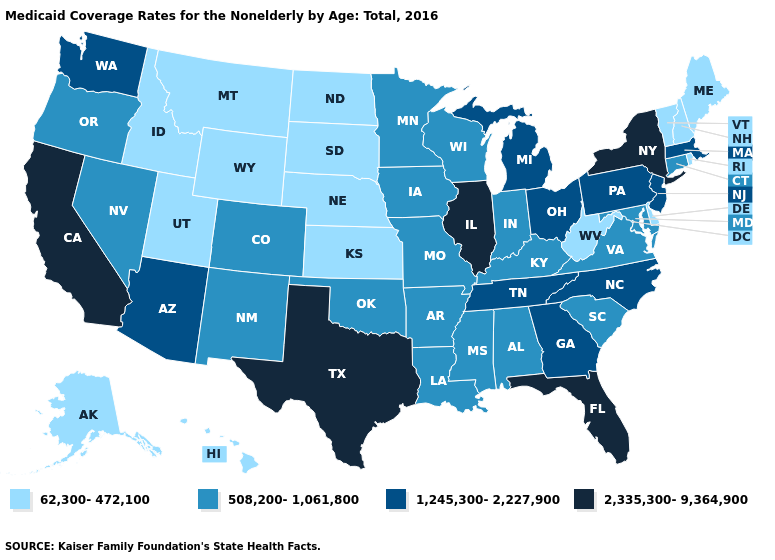Does Florida have the highest value in the South?
Short answer required. Yes. What is the value of Hawaii?
Short answer required. 62,300-472,100. What is the highest value in the South ?
Quick response, please. 2,335,300-9,364,900. What is the value of South Carolina?
Keep it brief. 508,200-1,061,800. Among the states that border North Carolina , does Georgia have the lowest value?
Answer briefly. No. What is the lowest value in the South?
Concise answer only. 62,300-472,100. What is the value of Massachusetts?
Give a very brief answer. 1,245,300-2,227,900. Name the states that have a value in the range 2,335,300-9,364,900?
Write a very short answer. California, Florida, Illinois, New York, Texas. Name the states that have a value in the range 508,200-1,061,800?
Keep it brief. Alabama, Arkansas, Colorado, Connecticut, Indiana, Iowa, Kentucky, Louisiana, Maryland, Minnesota, Mississippi, Missouri, Nevada, New Mexico, Oklahoma, Oregon, South Carolina, Virginia, Wisconsin. Does the map have missing data?
Short answer required. No. Does the first symbol in the legend represent the smallest category?
Short answer required. Yes. Name the states that have a value in the range 508,200-1,061,800?
Answer briefly. Alabama, Arkansas, Colorado, Connecticut, Indiana, Iowa, Kentucky, Louisiana, Maryland, Minnesota, Mississippi, Missouri, Nevada, New Mexico, Oklahoma, Oregon, South Carolina, Virginia, Wisconsin. Among the states that border Iowa , does South Dakota have the lowest value?
Quick response, please. Yes. What is the value of Minnesota?
Answer briefly. 508,200-1,061,800. Name the states that have a value in the range 508,200-1,061,800?
Keep it brief. Alabama, Arkansas, Colorado, Connecticut, Indiana, Iowa, Kentucky, Louisiana, Maryland, Minnesota, Mississippi, Missouri, Nevada, New Mexico, Oklahoma, Oregon, South Carolina, Virginia, Wisconsin. 